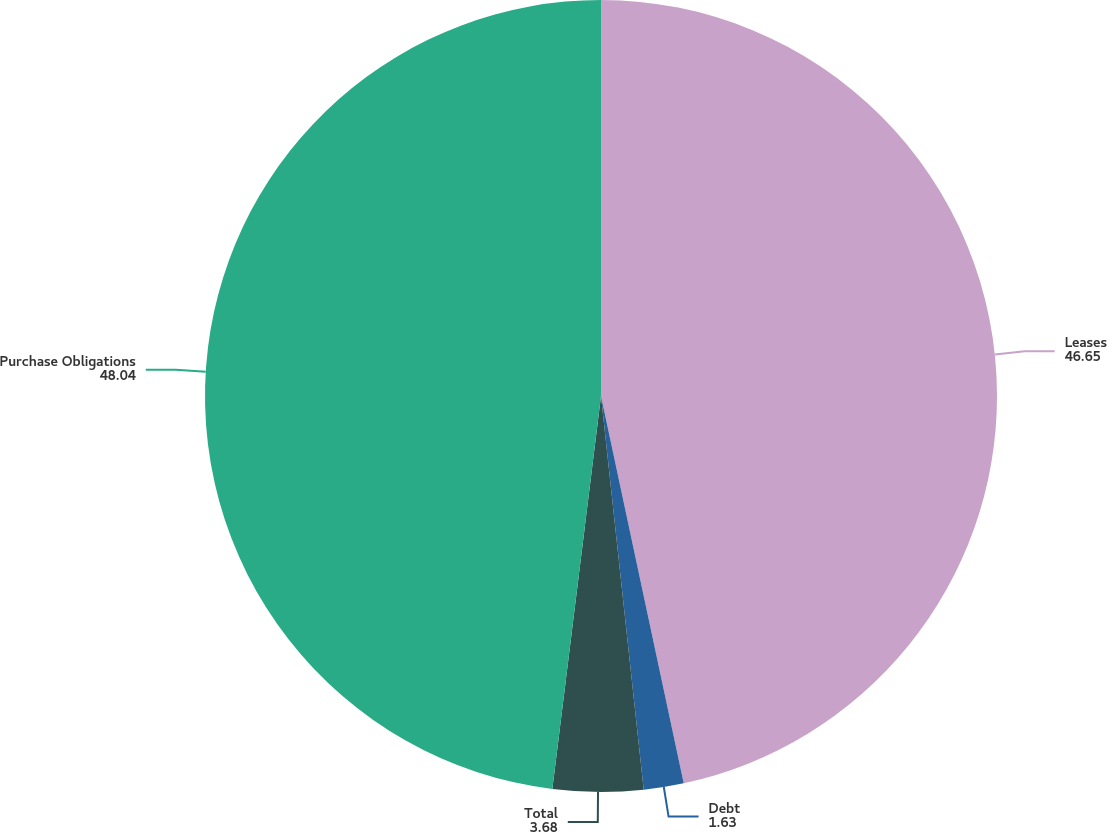<chart> <loc_0><loc_0><loc_500><loc_500><pie_chart><fcel>Leases<fcel>Debt<fcel>Total<fcel>Purchase Obligations<nl><fcel>46.65%<fcel>1.63%<fcel>3.68%<fcel>48.04%<nl></chart> 